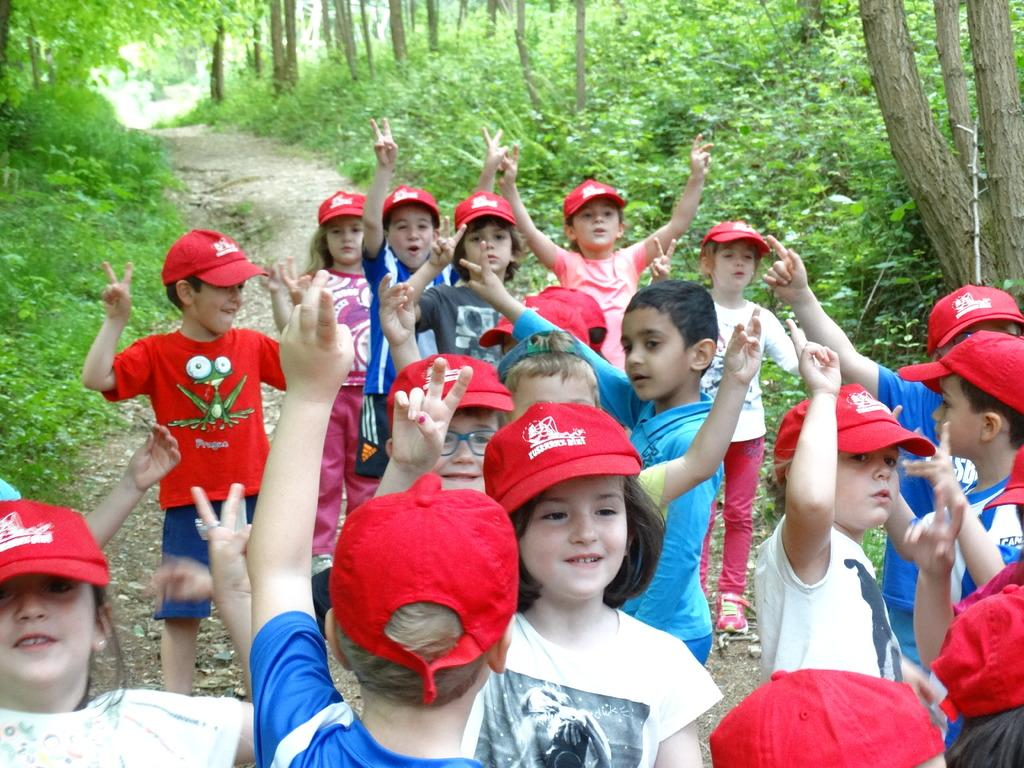What can be seen at the bottom of the image? There are people standing at the bottom of the image. What is the facial expression of the people in the image? The people are smiling. What type of vegetation is visible behind the people? There are trees behind the people. What type of ground surface is visible in the image? There is grass visible in the image. What type of plantation is visible in the image? There is no plantation present in the image; it features people standing in front of trees and grass. What type of board can be seen being traded among the people in the image? There is no board or trading activity visible in the image. 